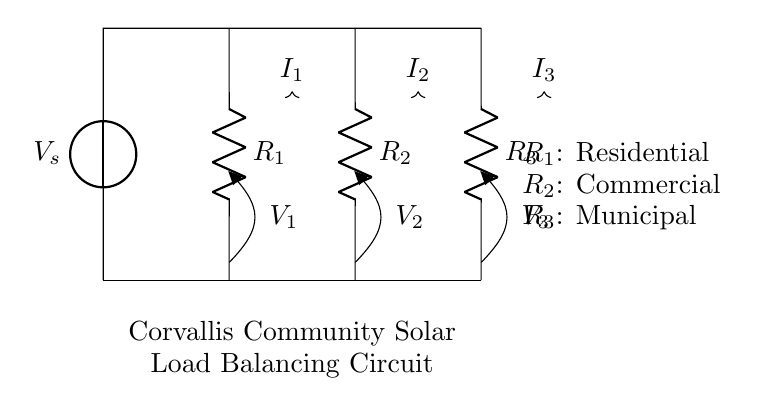What is the source voltage in this circuit? The voltage source, labeled as V_s, represents the source voltage, which supplies electrical energy to the circuit. The diagram shows no specific value, so we refer simply to it as V_s.
Answer: V_s What are the values of the resistors R1, R2, and R3? The diagram does not specify numeric values for the resistors; however, they are labeled R1, R2, and R3, indicating their positions. In this configuration, R1 is for residential load, R2 is for commercial load, and R3 is for municipal load.
Answer: R1, R2, R3 How many current pathways are present in this circuit? The circuit is a parallel configuration with three resistors, creating three distinct pathways for current flow. Each resistor corresponds to a separate load, contributing to the current division in the circuit.
Answer: Three What determines the amount of current through each resistor? The current through each resistor is determined by the load it represents and the resistance value, following the current divider rule, which states that the current is inversely proportional to the resistance in parallel circuits. Thus, lower resistance will allow higher current.
Answer: Resistance values Which resistor corresponds to the municipal load? In the diagram, the resistor labeled R3 is indicated to correspond to the municipal load. It is the third resistor in the parallel configuration.
Answer: R3 What happens to the total current supplied by the source? The total current supplied by the source is divided among the three resistors according to their resistances. Some portion goes through R1, another through R2, and the remainder goes through R3, maintaining the total equal to the source current.
Answer: It is divided among resistors How do you ensure balance in a solar power project with this circuit? To ensure balance, it is essential to design the load (resistances) such that their values distribute the total current proportionally based on the needs of each load, aligning with the current divider rule to maintain balance in the solar output.
Answer: By balancing resistance values 